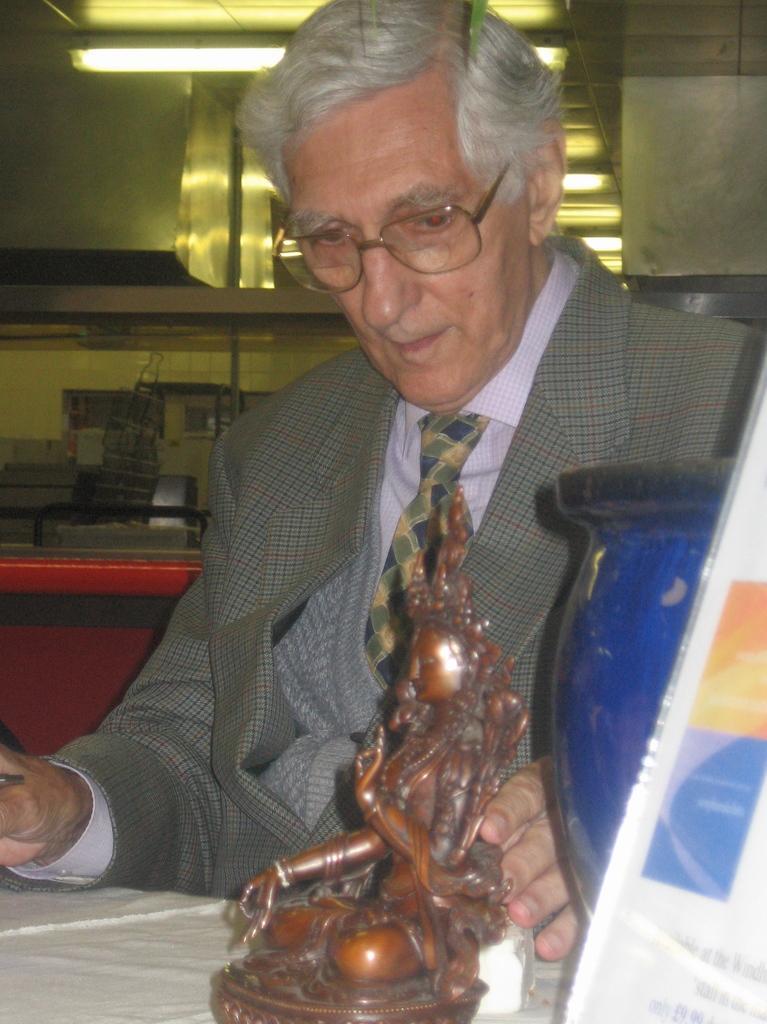Describe this image in one or two sentences. In this image, we can see an old woman is wearing a suit and holding some sculpture. It is on white surface. On the right side, we can see poster and object. Background we can see iron objects, light, rod, some objects. 